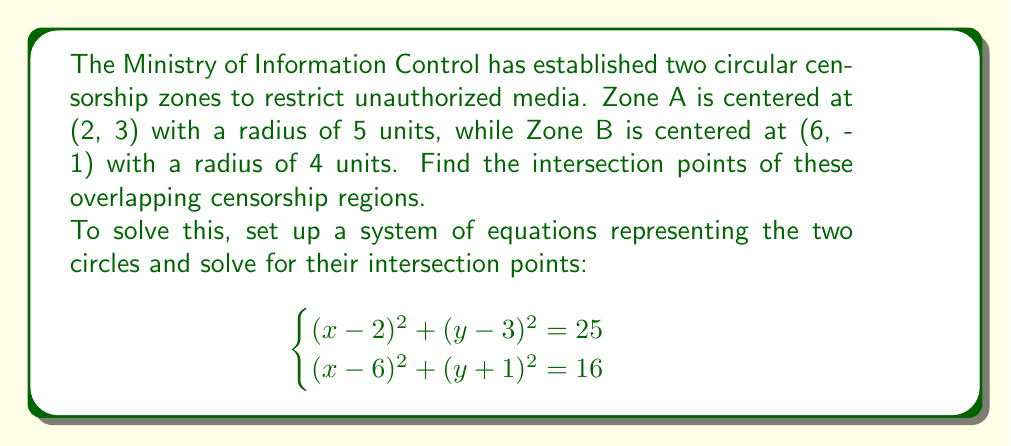What is the answer to this math problem? To find the intersection points of the two circular censorship zones, we need to solve the system of equations:

$$\begin{cases}
(x-2)^2 + (y-3)^2 = 25 \quad \text{(Equation 1)} \\
(x-6)^2 + (y+1)^2 = 16 \quad \text{(Equation 2)}
\end{cases}$$

Step 1: Expand the equations
Equation 1: $x^2 - 4x + 4 + y^2 - 6y + 9 = 25$
Equation 2: $x^2 - 12x + 36 + y^2 + 2y + 1 = 16$

Step 2: Simplify
Equation 1: $x^2 + y^2 - 4x - 6y - 12 = 0$
Equation 2: $x^2 + y^2 - 12x + 2y + 21 = 0$

Step 3: Subtract Equation 2 from Equation 1 to eliminate $x^2$ and $y^2$
$8x - 8y - 33 = 0$

Step 4: Solve for y in terms of x
$y = x - \frac{33}{8}$

Step 5: Substitute this expression for y into Equation 1
$x^2 + (x - \frac{33}{8})^2 - 4x - 6(x - \frac{33}{8}) - 12 = 0$

Step 6: Expand and simplify
$2x^2 - 5x - \frac{231}{16} = 0$

Step 7: Multiply by 16 to eliminate fractions
$32x^2 - 80x - 231 = 0$

Step 8: Solve the quadratic equation using the quadratic formula
$x = \frac{80 \pm \sqrt{6400 + 4(32)(231)}}{2(32)} = \frac{80 \pm \sqrt{9184}}{64} = \frac{80 \pm 95.83}{64}$

$x_1 = \frac{80 + 95.83}{64} \approx 5.21$
$x_2 = \frac{80 - 95.83}{64} \approx 4.79$

Step 9: Calculate the corresponding y-values
$y_1 = 5.21 - \frac{33}{8} \approx 6.16$
$y_2 = 4.79 - \frac{33}{8} \approx -0.16$

Therefore, the intersection points are approximately (5.21, 6.16) and (4.79, -0.16).
Answer: The intersection points of the overlapping censorship regions are approximately (5.21, 6.16) and (4.79, -0.16). 